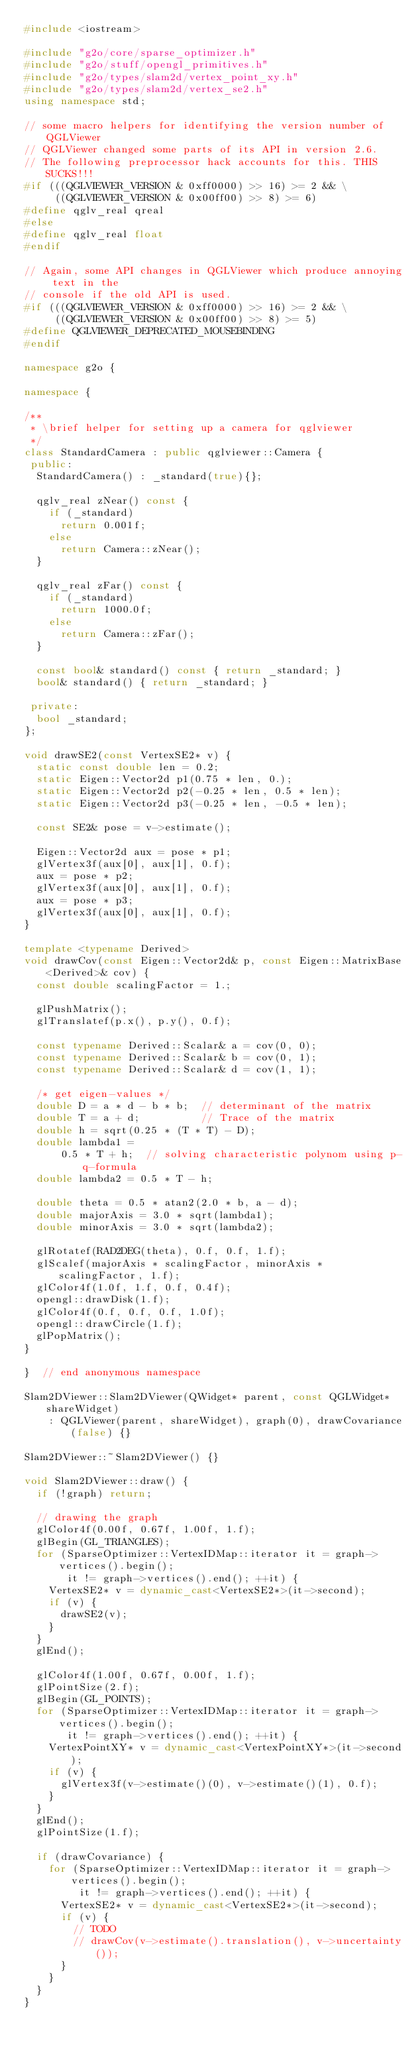Convert code to text. <code><loc_0><loc_0><loc_500><loc_500><_C++_>#include <iostream>

#include "g2o/core/sparse_optimizer.h"
#include "g2o/stuff/opengl_primitives.h"
#include "g2o/types/slam2d/vertex_point_xy.h"
#include "g2o/types/slam2d/vertex_se2.h"
using namespace std;

// some macro helpers for identifying the version number of QGLViewer
// QGLViewer changed some parts of its API in version 2.6.
// The following preprocessor hack accounts for this. THIS SUCKS!!!
#if (((QGLVIEWER_VERSION & 0xff0000) >> 16) >= 2 && \
     ((QGLVIEWER_VERSION & 0x00ff00) >> 8) >= 6)
#define qglv_real qreal
#else
#define qglv_real float
#endif

// Again, some API changes in QGLViewer which produce annoying text in the
// console if the old API is used.
#if (((QGLVIEWER_VERSION & 0xff0000) >> 16) >= 2 && \
     ((QGLVIEWER_VERSION & 0x00ff00) >> 8) >= 5)
#define QGLVIEWER_DEPRECATED_MOUSEBINDING
#endif

namespace g2o {

namespace {

/**
 * \brief helper for setting up a camera for qglviewer
 */
class StandardCamera : public qglviewer::Camera {
 public:
  StandardCamera() : _standard(true){};

  qglv_real zNear() const {
    if (_standard)
      return 0.001f;
    else
      return Camera::zNear();
  }

  qglv_real zFar() const {
    if (_standard)
      return 1000.0f;
    else
      return Camera::zFar();
  }

  const bool& standard() const { return _standard; }
  bool& standard() { return _standard; }

 private:
  bool _standard;
};

void drawSE2(const VertexSE2* v) {
  static const double len = 0.2;
  static Eigen::Vector2d p1(0.75 * len, 0.);
  static Eigen::Vector2d p2(-0.25 * len, 0.5 * len);
  static Eigen::Vector2d p3(-0.25 * len, -0.5 * len);

  const SE2& pose = v->estimate();

  Eigen::Vector2d aux = pose * p1;
  glVertex3f(aux[0], aux[1], 0.f);
  aux = pose * p2;
  glVertex3f(aux[0], aux[1], 0.f);
  aux = pose * p3;
  glVertex3f(aux[0], aux[1], 0.f);
}

template <typename Derived>
void drawCov(const Eigen::Vector2d& p, const Eigen::MatrixBase<Derived>& cov) {
  const double scalingFactor = 1.;

  glPushMatrix();
  glTranslatef(p.x(), p.y(), 0.f);

  const typename Derived::Scalar& a = cov(0, 0);
  const typename Derived::Scalar& b = cov(0, 1);
  const typename Derived::Scalar& d = cov(1, 1);

  /* get eigen-values */
  double D = a * d - b * b;  // determinant of the matrix
  double T = a + d;          // Trace of the matrix
  double h = sqrt(0.25 * (T * T) - D);
  double lambda1 =
      0.5 * T + h;  // solving characteristic polynom using p-q-formula
  double lambda2 = 0.5 * T - h;

  double theta = 0.5 * atan2(2.0 * b, a - d);
  double majorAxis = 3.0 * sqrt(lambda1);
  double minorAxis = 3.0 * sqrt(lambda2);

  glRotatef(RAD2DEG(theta), 0.f, 0.f, 1.f);
  glScalef(majorAxis * scalingFactor, minorAxis * scalingFactor, 1.f);
  glColor4f(1.0f, 1.f, 0.f, 0.4f);
  opengl::drawDisk(1.f);
  glColor4f(0.f, 0.f, 0.f, 1.0f);
  opengl::drawCircle(1.f);
  glPopMatrix();
}

}  // end anonymous namespace

Slam2DViewer::Slam2DViewer(QWidget* parent, const QGLWidget* shareWidget)
    : QGLViewer(parent, shareWidget), graph(0), drawCovariance(false) {}

Slam2DViewer::~Slam2DViewer() {}

void Slam2DViewer::draw() {
  if (!graph) return;

  // drawing the graph
  glColor4f(0.00f, 0.67f, 1.00f, 1.f);
  glBegin(GL_TRIANGLES);
  for (SparseOptimizer::VertexIDMap::iterator it = graph->vertices().begin();
       it != graph->vertices().end(); ++it) {
    VertexSE2* v = dynamic_cast<VertexSE2*>(it->second);
    if (v) {
      drawSE2(v);
    }
  }
  glEnd();

  glColor4f(1.00f, 0.67f, 0.00f, 1.f);
  glPointSize(2.f);
  glBegin(GL_POINTS);
  for (SparseOptimizer::VertexIDMap::iterator it = graph->vertices().begin();
       it != graph->vertices().end(); ++it) {
    VertexPointXY* v = dynamic_cast<VertexPointXY*>(it->second);
    if (v) {
      glVertex3f(v->estimate()(0), v->estimate()(1), 0.f);
    }
  }
  glEnd();
  glPointSize(1.f);

  if (drawCovariance) {
    for (SparseOptimizer::VertexIDMap::iterator it = graph->vertices().begin();
         it != graph->vertices().end(); ++it) {
      VertexSE2* v = dynamic_cast<VertexSE2*>(it->second);
      if (v) {
        // TODO
        // drawCov(v->estimate().translation(), v->uncertainty());
      }
    }
  }
}
</code> 